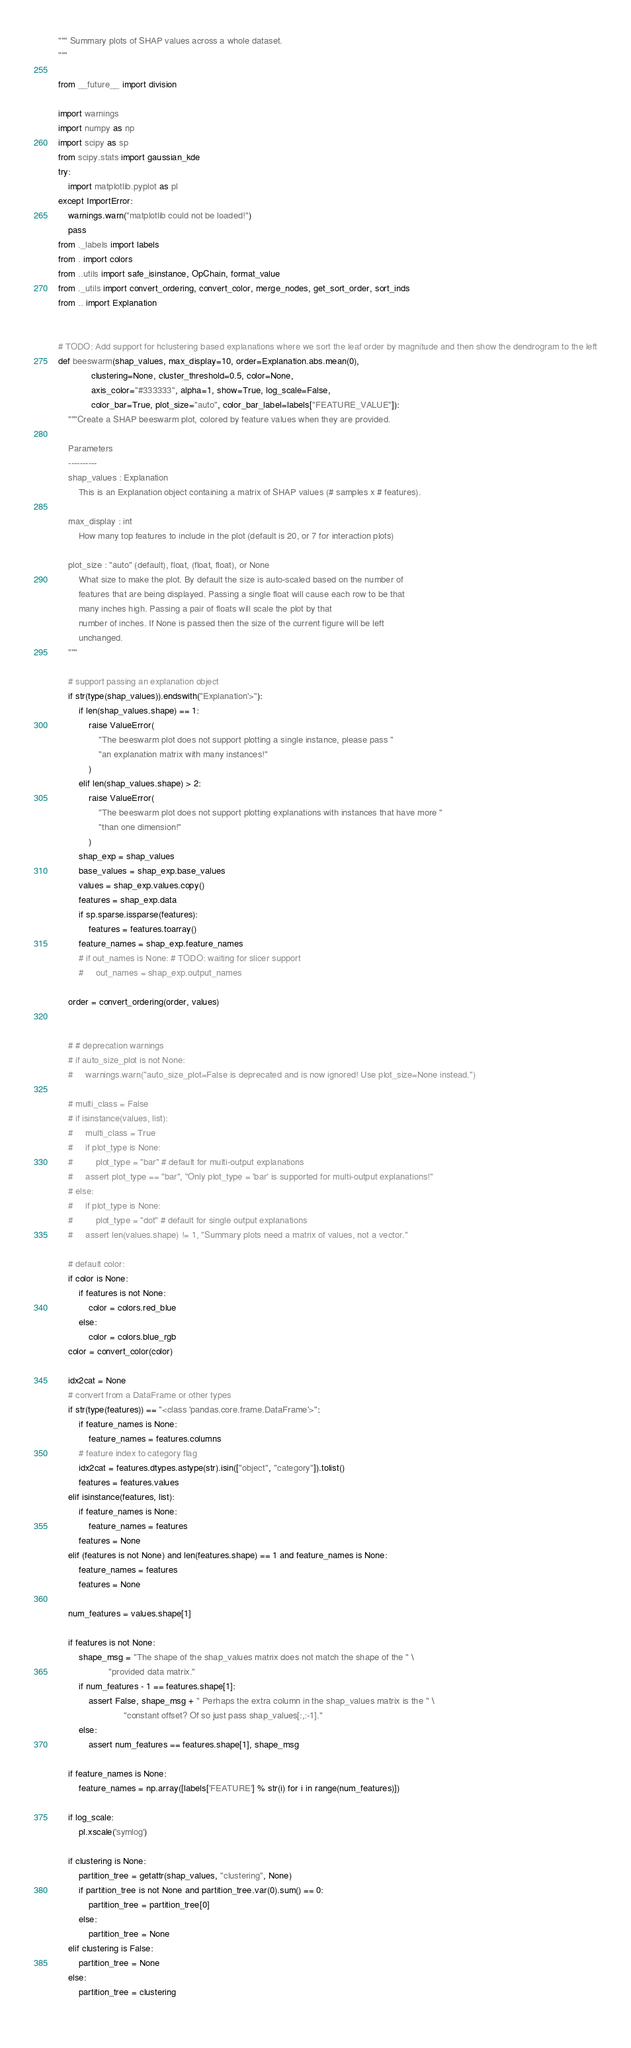Convert code to text. <code><loc_0><loc_0><loc_500><loc_500><_Python_>""" Summary plots of SHAP values across a whole dataset.
"""

from __future__ import division

import warnings
import numpy as np
import scipy as sp
from scipy.stats import gaussian_kde
try:
    import matplotlib.pyplot as pl
except ImportError:
    warnings.warn("matplotlib could not be loaded!")
    pass
from ._labels import labels
from . import colors
from ..utils import safe_isinstance, OpChain, format_value
from ._utils import convert_ordering, convert_color, merge_nodes, get_sort_order, sort_inds
from .. import Explanation


# TODO: Add support for hclustering based explanations where we sort the leaf order by magnitude and then show the dendrogram to the left
def beeswarm(shap_values, max_display=10, order=Explanation.abs.mean(0),
             clustering=None, cluster_threshold=0.5, color=None,
             axis_color="#333333", alpha=1, show=True, log_scale=False,
             color_bar=True, plot_size="auto", color_bar_label=labels["FEATURE_VALUE"]):
    """Create a SHAP beeswarm plot, colored by feature values when they are provided.

    Parameters
    ----------
    shap_values : Explanation
        This is an Explanation object containing a matrix of SHAP values (# samples x # features).

    max_display : int
        How many top features to include in the plot (default is 20, or 7 for interaction plots)

    plot_size : "auto" (default), float, (float, float), or None
        What size to make the plot. By default the size is auto-scaled based on the number of
        features that are being displayed. Passing a single float will cause each row to be that 
        many inches high. Passing a pair of floats will scale the plot by that
        number of inches. If None is passed then the size of the current figure will be left
        unchanged.
    """

    # support passing an explanation object
    if str(type(shap_values)).endswith("Explanation'>"):
        if len(shap_values.shape) == 1:
            raise ValueError(
                "The beeswarm plot does not support plotting a single instance, please pass "
                "an explanation matrix with many instances!"
            )
        elif len(shap_values.shape) > 2:
            raise ValueError(
                "The beeswarm plot does not support plotting explanations with instances that have more "
                "than one dimension!"
            )
        shap_exp = shap_values
        base_values = shap_exp.base_values
        values = shap_exp.values.copy()
        features = shap_exp.data
        if sp.sparse.issparse(features):
            features = features.toarray()
        feature_names = shap_exp.feature_names
        # if out_names is None: # TODO: waiting for slicer support
        #     out_names = shap_exp.output_names

    order = convert_ordering(order, values)
    

    # # deprecation warnings
    # if auto_size_plot is not None:
    #     warnings.warn("auto_size_plot=False is deprecated and is now ignored! Use plot_size=None instead.")

    # multi_class = False
    # if isinstance(values, list):
    #     multi_class = True
    #     if plot_type is None:
    #         plot_type = "bar" # default for multi-output explanations
    #     assert plot_type == "bar", "Only plot_type = 'bar' is supported for multi-output explanations!"
    # else:
    #     if plot_type is None:
    #         plot_type = "dot" # default for single output explanations
    #     assert len(values.shape) != 1, "Summary plots need a matrix of values, not a vector."

    # default color:
    if color is None:
        if features is not None:
            color = colors.red_blue
        else:
            color = colors.blue_rgb
    color = convert_color(color)

    idx2cat = None
    # convert from a DataFrame or other types
    if str(type(features)) == "<class 'pandas.core.frame.DataFrame'>":
        if feature_names is None:
            feature_names = features.columns
        # feature index to category flag
        idx2cat = features.dtypes.astype(str).isin(["object", "category"]).tolist()
        features = features.values
    elif isinstance(features, list):
        if feature_names is None:
            feature_names = features
        features = None
    elif (features is not None) and len(features.shape) == 1 and feature_names is None:
        feature_names = features
        features = None

    num_features = values.shape[1]

    if features is not None:
        shape_msg = "The shape of the shap_values matrix does not match the shape of the " \
                    "provided data matrix."
        if num_features - 1 == features.shape[1]:
            assert False, shape_msg + " Perhaps the extra column in the shap_values matrix is the " \
                          "constant offset? Of so just pass shap_values[:,:-1]."
        else:
            assert num_features == features.shape[1], shape_msg

    if feature_names is None:
        feature_names = np.array([labels['FEATURE'] % str(i) for i in range(num_features)])

    if log_scale:
        pl.xscale('symlog')

    if clustering is None:
        partition_tree = getattr(shap_values, "clustering", None)
        if partition_tree is not None and partition_tree.var(0).sum() == 0:
            partition_tree = partition_tree[0]
        else:
            partition_tree = None
    elif clustering is False:
        partition_tree = None
    else:
        partition_tree = clustering
    </code> 